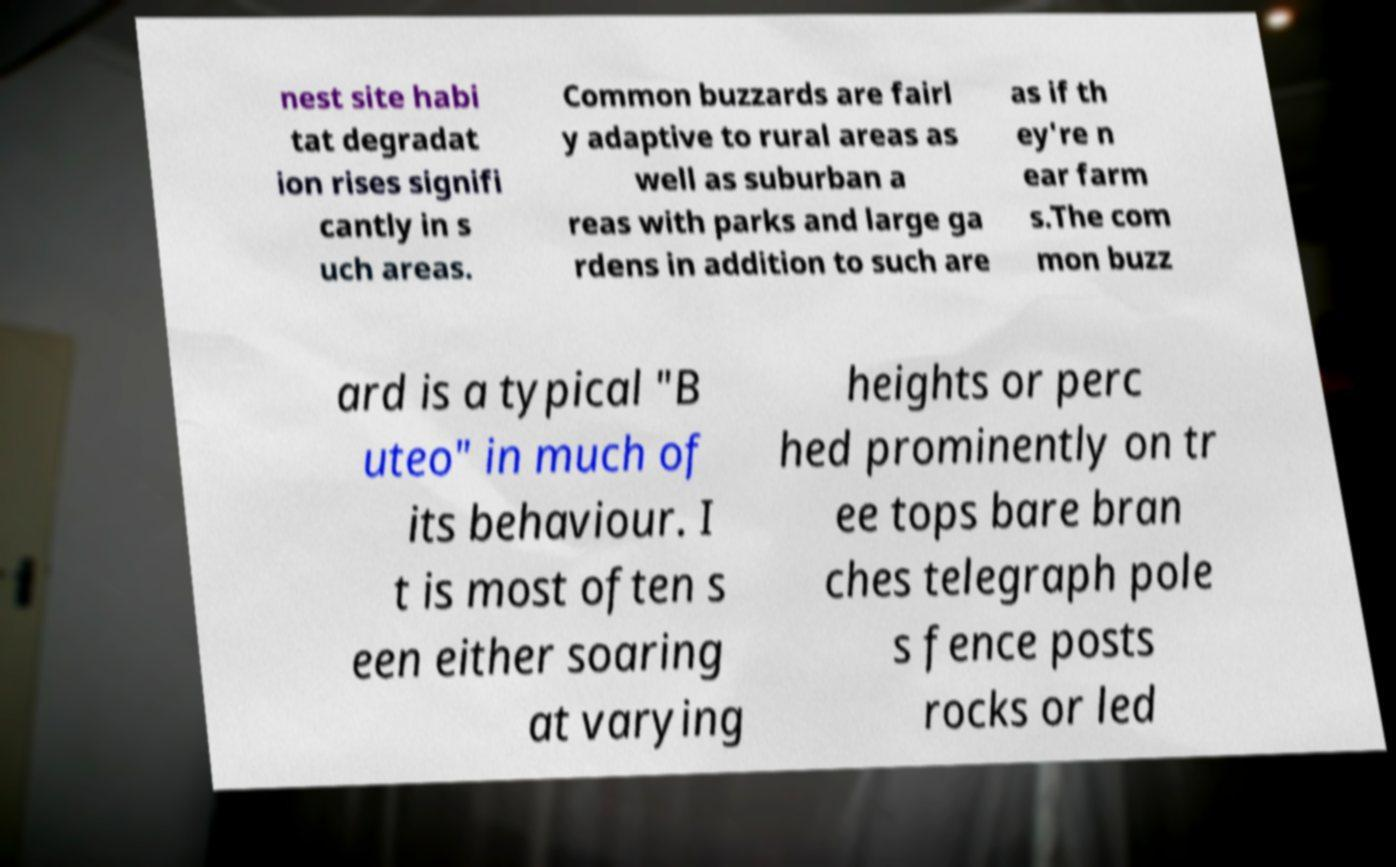Can you accurately transcribe the text from the provided image for me? nest site habi tat degradat ion rises signifi cantly in s uch areas. Common buzzards are fairl y adaptive to rural areas as well as suburban a reas with parks and large ga rdens in addition to such are as if th ey're n ear farm s.The com mon buzz ard is a typical "B uteo" in much of its behaviour. I t is most often s een either soaring at varying heights or perc hed prominently on tr ee tops bare bran ches telegraph pole s fence posts rocks or led 